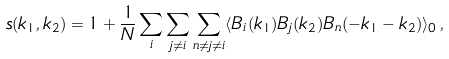<formula> <loc_0><loc_0><loc_500><loc_500>s ( { k } _ { 1 } , { k } _ { 2 } ) = 1 + \frac { 1 } { N } \sum _ { i } \sum _ { j \neq i } \sum _ { n \neq j \neq i } \langle B _ { i } ( { k } _ { 1 } ) B _ { j } ( { k } _ { 2 } ) B _ { n } ( - { k } _ { 1 } - { k } _ { 2 } ) \rangle _ { 0 } \, ,</formula> 